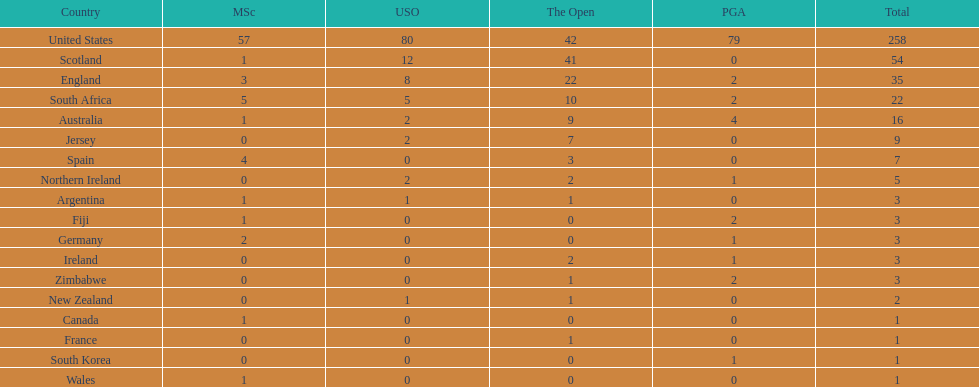What are the number of pga winning golfers that zimbabwe has? 2. 